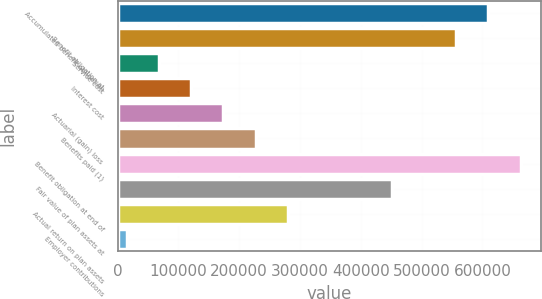Convert chart. <chart><loc_0><loc_0><loc_500><loc_500><bar_chart><fcel>Accumulated benefit obligation<fcel>Benefit obligation at<fcel>Service cost<fcel>Interest cost<fcel>Actuarial (gain) loss<fcel>Benefits paid (1)<fcel>Benefit obligation at end of<fcel>Fair value of plan assets at<fcel>Actual return on plan assets<fcel>Employer contributions<nl><fcel>610076<fcel>557028<fcel>68048<fcel>121096<fcel>174144<fcel>227192<fcel>663124<fcel>450932<fcel>280240<fcel>15000<nl></chart> 